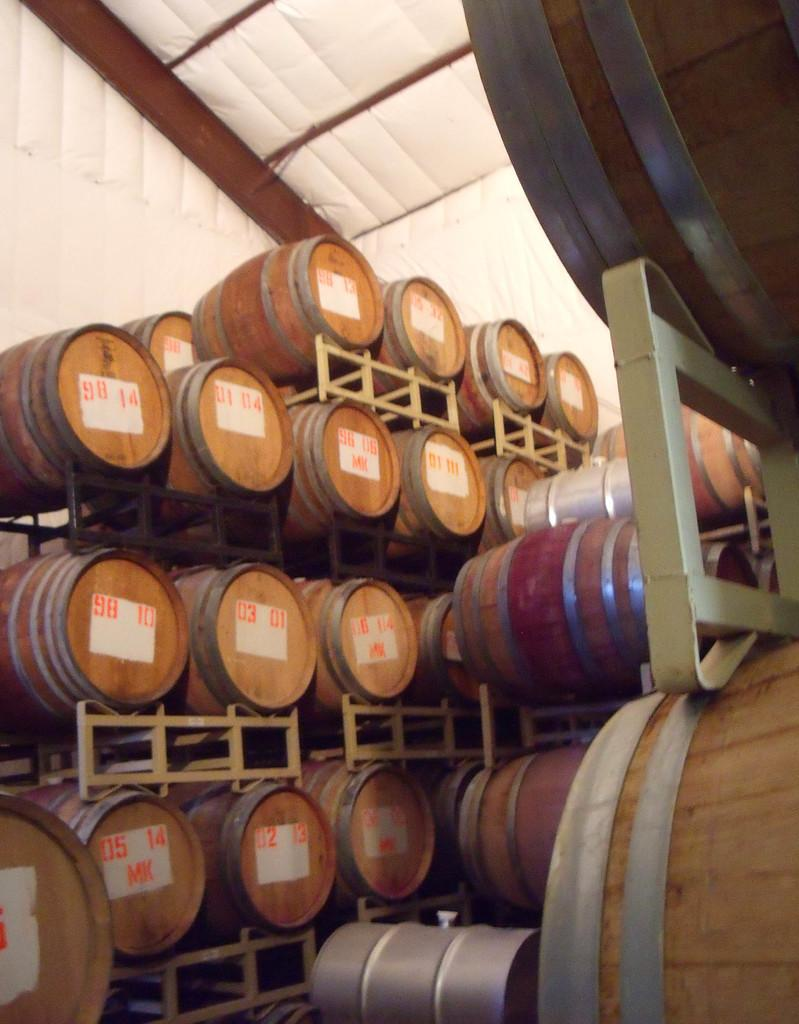What type of containers are present in the image? There are wooden barrels in the image. How are the wooden barrels supported? The wooden barrels are placed on rod stands. Are there any markings on the wooden barrels? Some wooden barrels have numbers and letters on them. What can be seen in the background of the image? There are white color objects and rods visible in the background of the image. What type of request can be seen on the wooden barrels in the image? There is no request visible on the wooden barrels in the image. What is the rate of the fan in the image? There is no fan present in the image. 